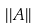Convert formula to latex. <formula><loc_0><loc_0><loc_500><loc_500>| | A | |</formula> 